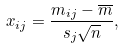Convert formula to latex. <formula><loc_0><loc_0><loc_500><loc_500>x _ { i j } = \frac { m _ { i j } - \overline { m } } { s _ { j } \sqrt { n } } ,</formula> 